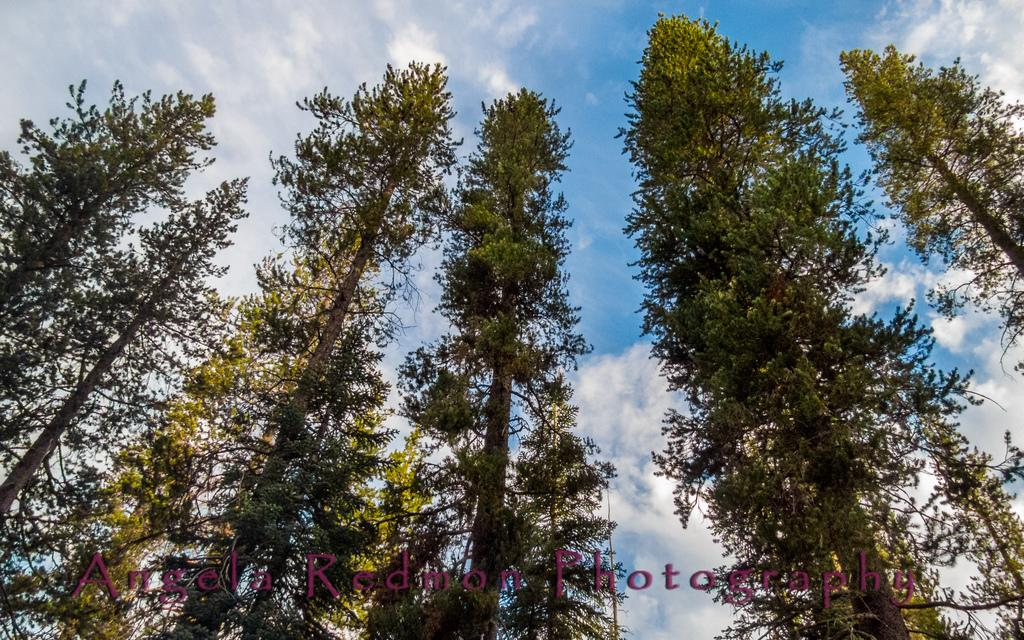What type of vegetation can be seen in the image? There are trees in the image. What is visible at the top of the image? The sky is visible at the top of the image. What can be observed in the sky? Clouds are present in the sky. What is written or printed at the bottom of the image? There is some text printed at the bottom of the image. Can you tell me how many jars are visible in the image? There are no jars present in the image. What type of club is shown in the image? There is no club depicted in the image. 